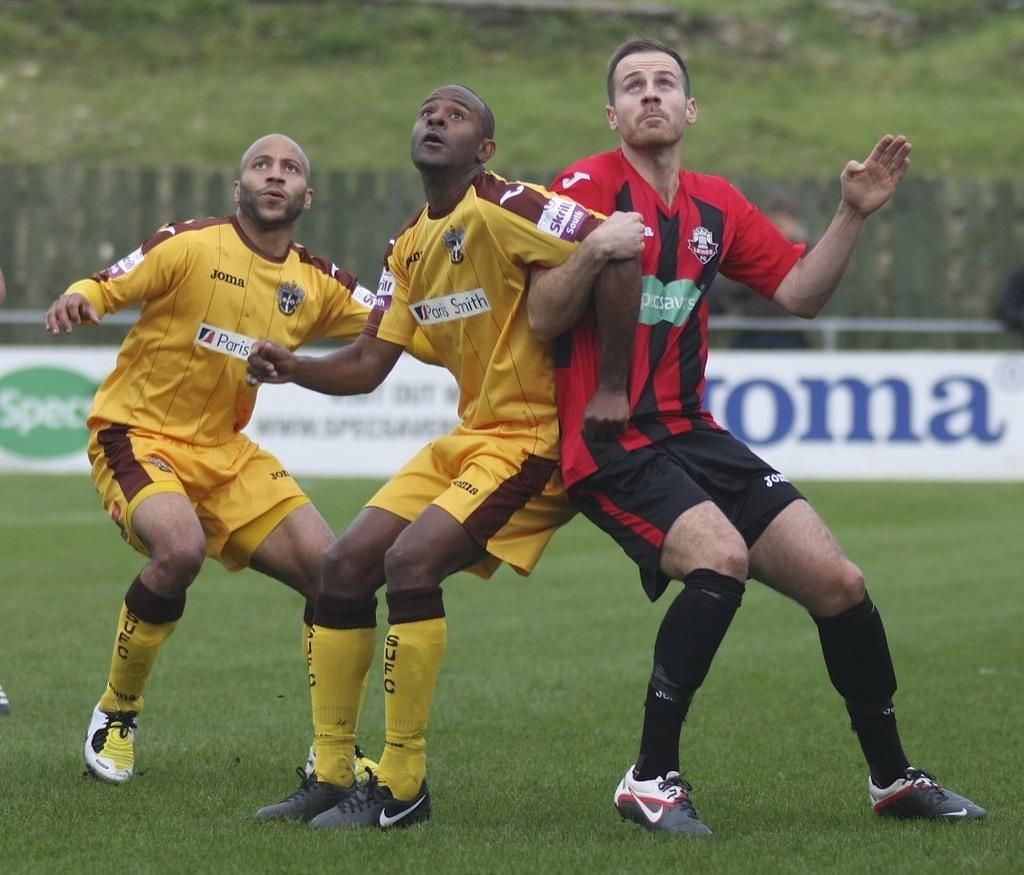<image>
Describe the image concisely. soccer players look up in the air while wearing Paris jerseys 